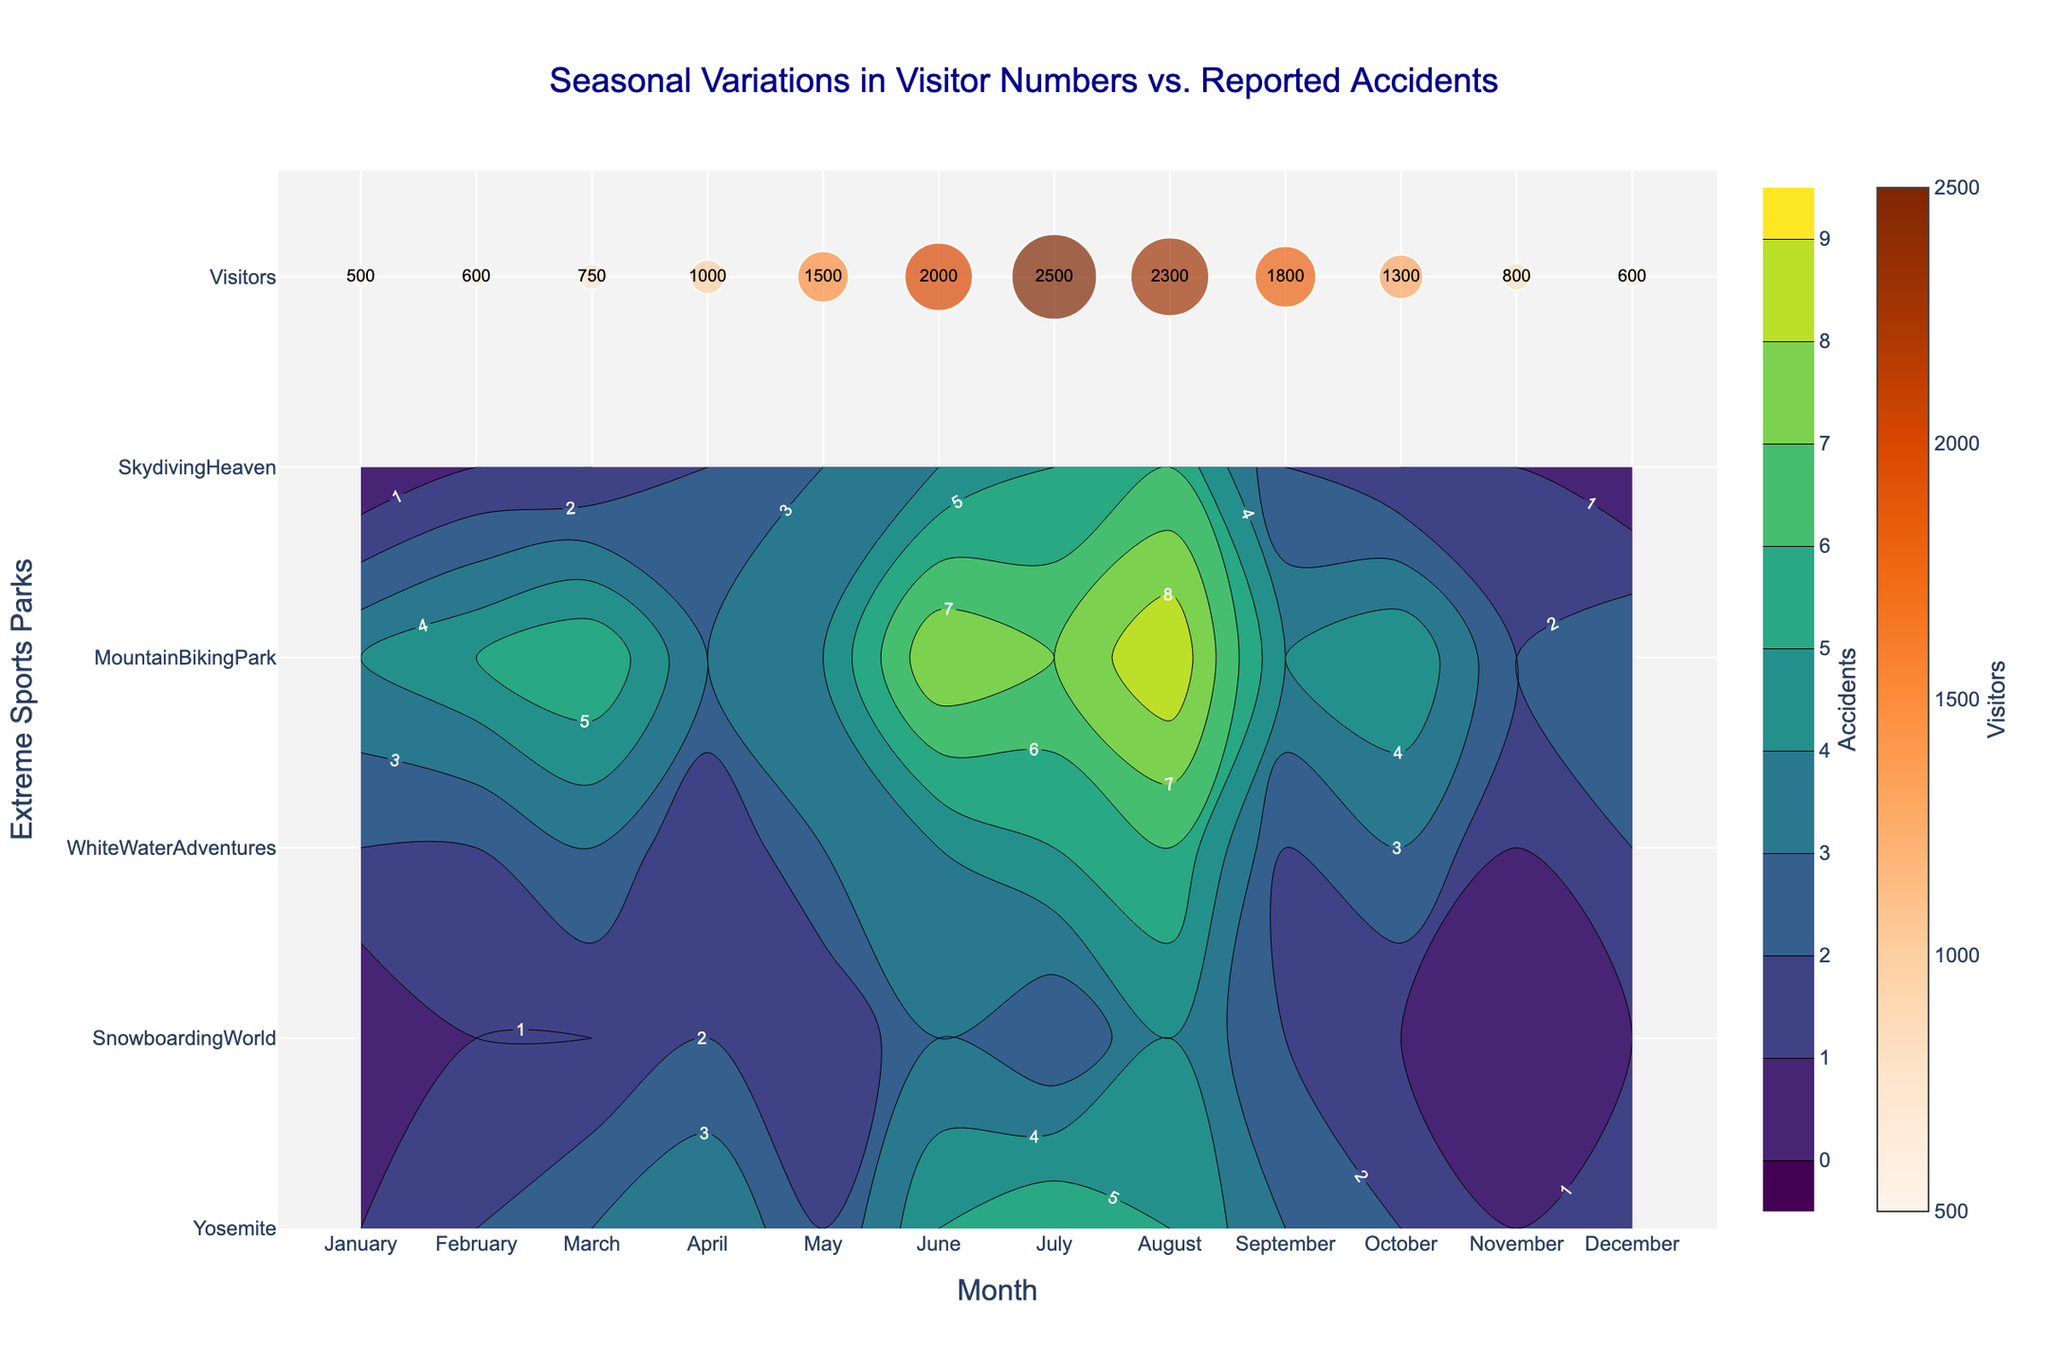What's the title of the plot? The title is located at the top of the plot and serves to give an overall description of the visualization.
Answer: Seasonal Variations in Visitor Numbers vs. Reported Accidents Which month had the highest number of accidents in Yosemite? Referring to the contour plot, find the peak or the darkest area associated with Yosemite along the x-axis labeled with months. The highest number is indicated by the darkest shading or labeled numbers.
Answer: July How many visitors were there in June? Looking at the scatter plot, identify the text labels within the orange markers aligning with June.
Answer: 2000 Which park saw the highest number of accidents in August? Check the contour plot's color intensity for the month of August across all parks. The park with the highest count will have the darkest shade or highest labeled number in August.
Answer: Skydiving Heaven What is the average number of accidents reported in SnowboardingWorld across the entire year? Sum up the number of accidents recorded each month for SnowboardingWorld and then divide by the number of months (12). The numbers are (0 + 1 + 1 + 2 + 1 + 3 + 2 + 4 + 2 + 1 + 0 + 1). The total is 18, and the average is 18/12.
Answer: 1.5 In which month did WhiteWaterAdventures report the lowest number of accidents? Identify the month with the lightest shading or lowest number in the WhiteWaterAdventures row looking at the contour plot.
Answer: November Compare the number of accidents in MountainBikingPark in April and July. Which month had more accidents? Refer to the labels or shading intensity in MountainBikingPark for April and July. April has 3 accidents whereas July has 7 accidents.
Answer: July What trend can you observe in the number of visitors from January to December? The scatter plot shows the visitors' *size* and *color*. Starting with small, less intense markers in January, gradually increasing to larger and more intense markers around mid-year, and then decreasing by December.
Answer: Increasing till July, then decreasing Which park had more accidents reported in June: Yosemite or Skydiving Heaven? Look at the contour plot for June and compare Yosemite (5 accidents) with Skydiving Heaven (4 accidents).
Answer: Yosemite Calculate the overall number of accidents in March across all parks? Sum the number of accidents from each park in March. Those numbers are Yosemite (3), SnowboardingWorld (1), WhiteWaterAdventures (3), MountainBikingPark (6), SkydivingHeaven (1). Summing them up gives 14.
Answer: 14 